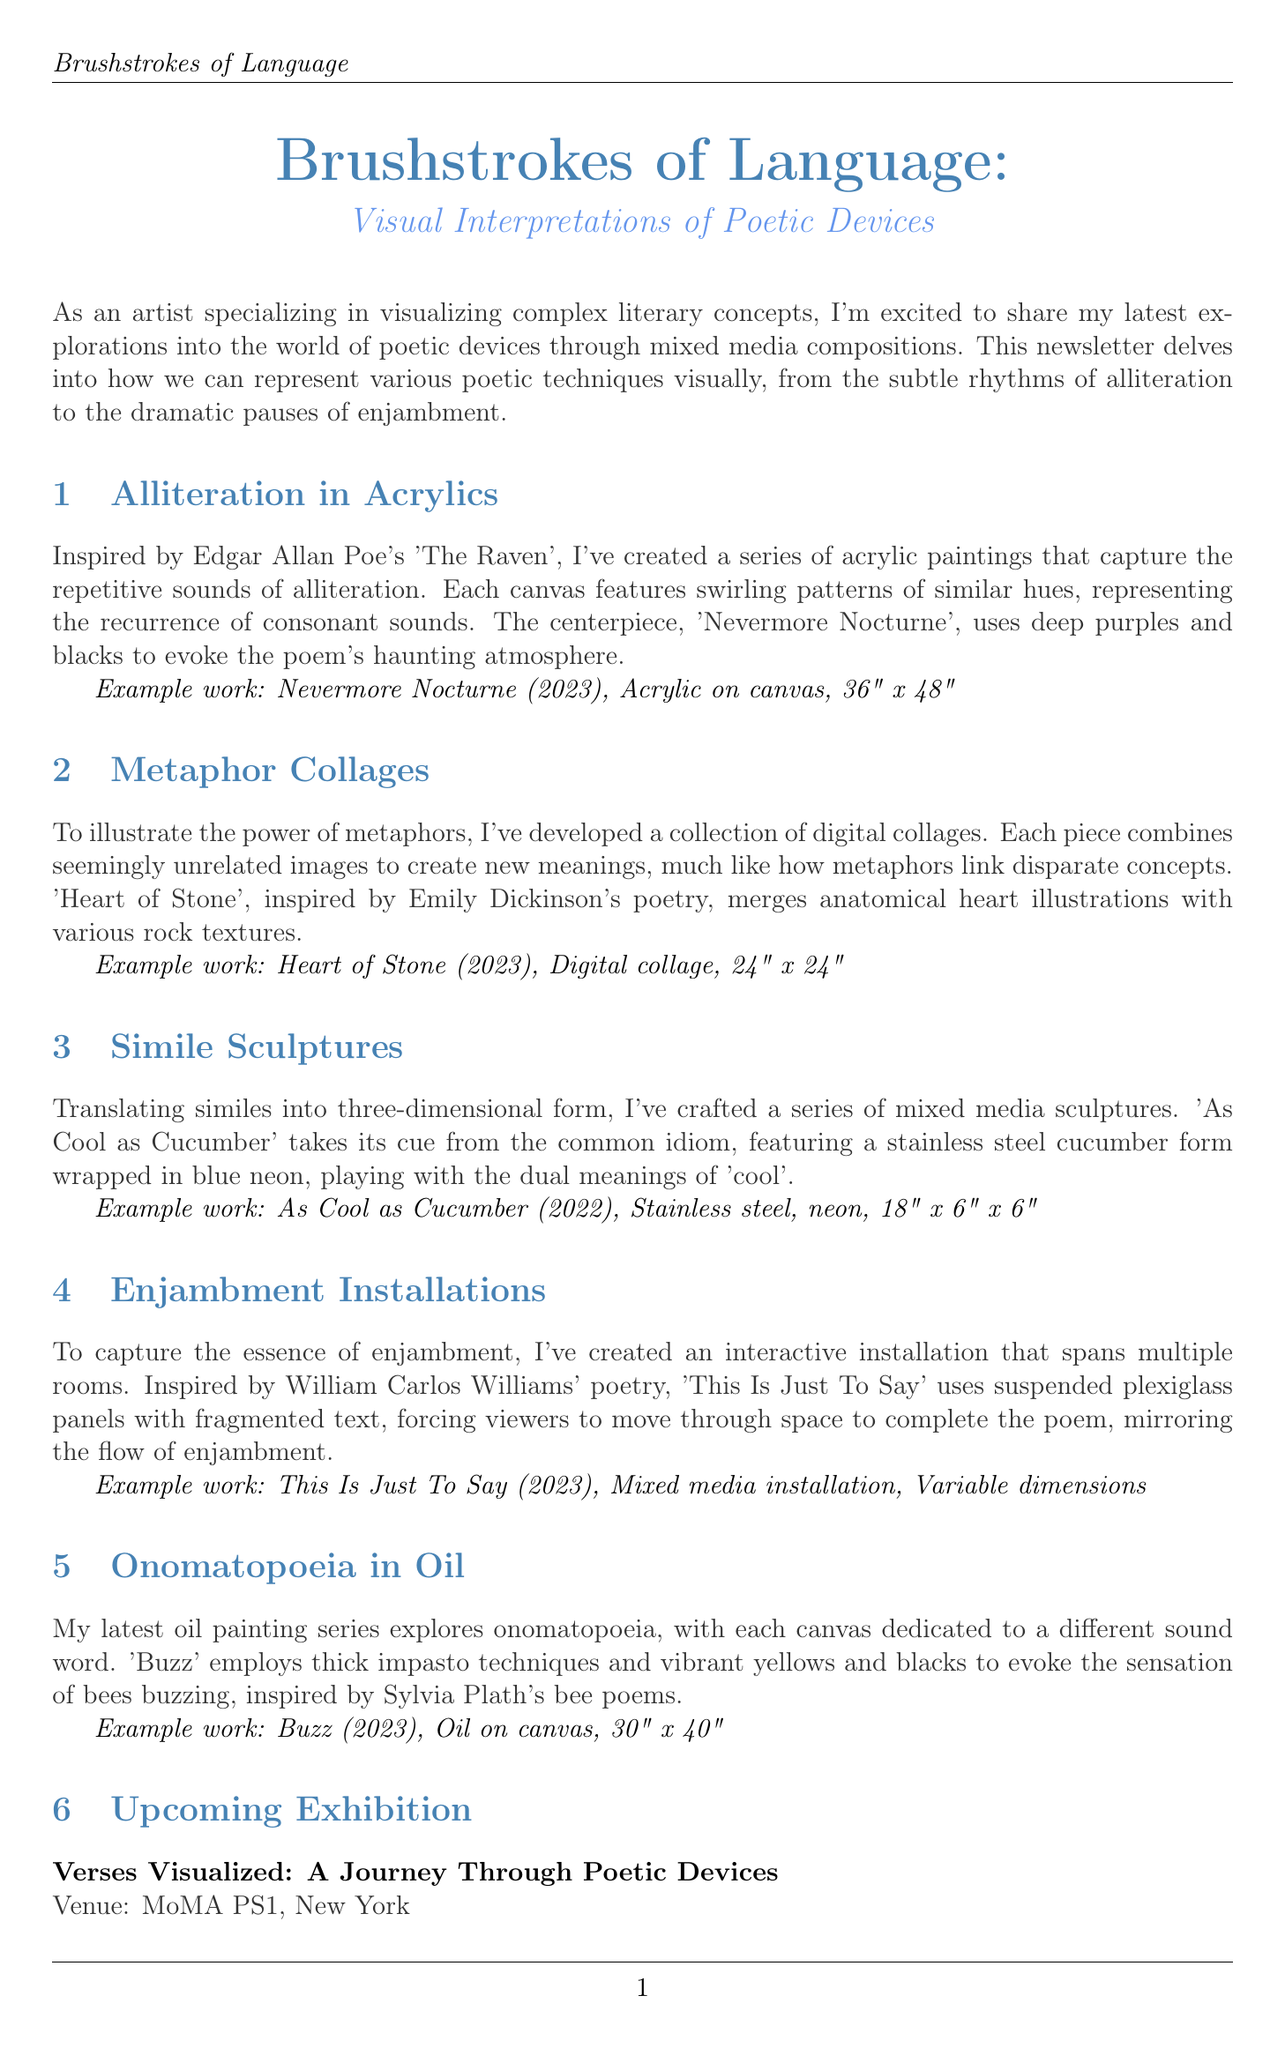what is the title of the newsletter? The title of the newsletter is clearly stated at the beginning of the document.
Answer: Brushstrokes of Language: Visual Interpretations of Poetic Devices what is the date for the upcoming exhibition? The exhibition date is explicitly listed in the upcoming exhibition section of the newsletter.
Answer: September 15 - December 31, 2023 how many works will be showcased in the upcoming exhibition? The number of works to be showcased is mentioned in the description of the upcoming exhibition.
Answer: over 50 what materials are used in the work "As Cool as Cucumber"? The materials used in the sculpture are detailed in the specific section for this work.
Answer: Stainless steel, neon how does the installation "This Is Just To Say" represent enjambment? The installation's concept and physical setup are explained, illustrating how it mirrors enjambment.
Answer: Suspended plexiglass panels with fragmented text what is the theme of the workshop being offered? The theme of the workshop is presented in the announcement section, summarizing its purpose.
Answer: Translating Literary Devices into Visual Art what poetic device is represented in the work "Buzz"? The artistic focus of this work is specifically mentioned in its section.
Answer: Onomatopoeia 